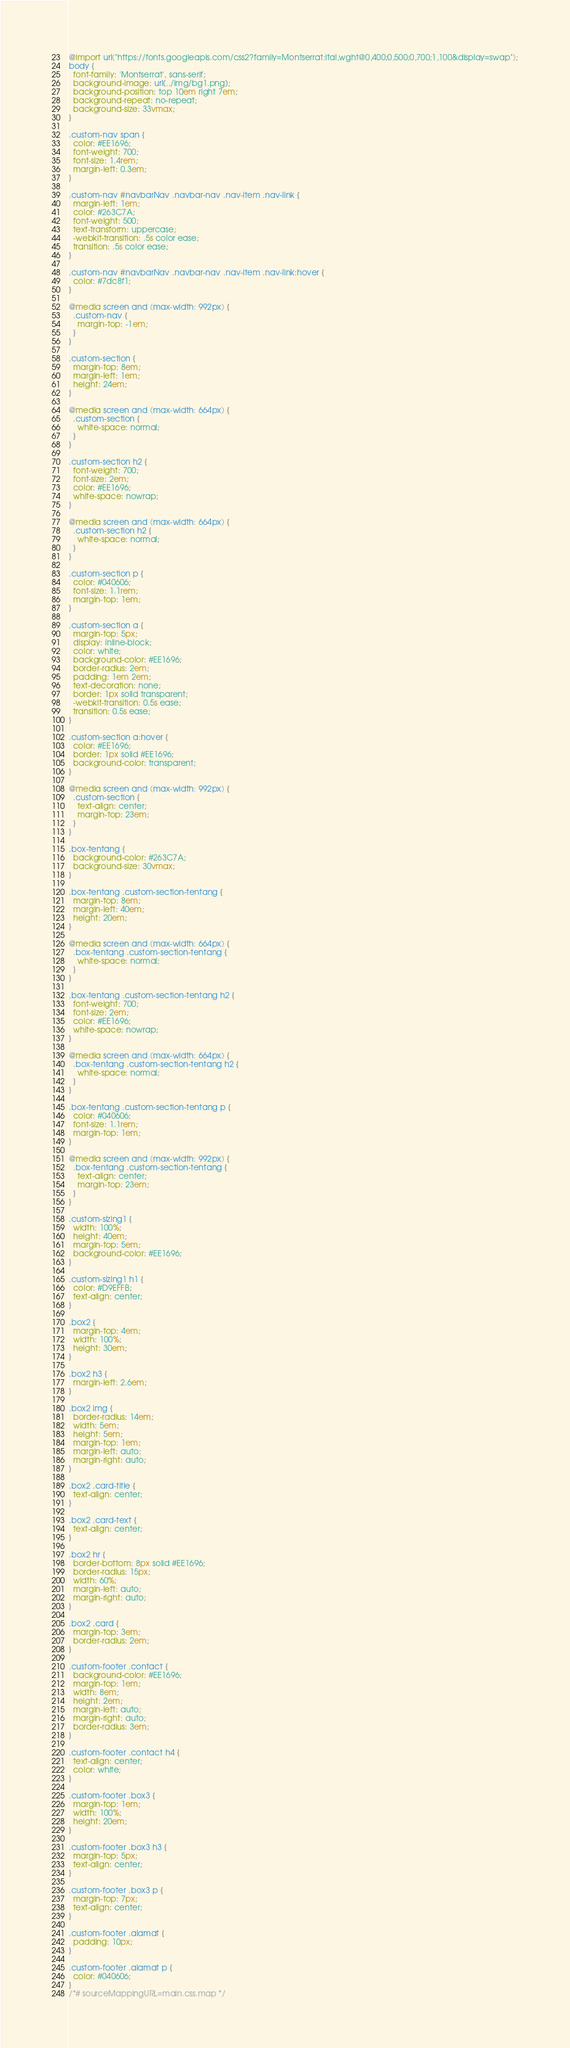Convert code to text. <code><loc_0><loc_0><loc_500><loc_500><_CSS_>@import url("https://fonts.googleapis.com/css2?family=Montserrat:ital,wght@0,400;0,500;0,700;1,100&display=swap");
body {
  font-family: 'Montserrat', sans-serif;
  background-image: url(../img/bg1.png);
  background-position: top 10em right 7em;
  background-repeat: no-repeat;
  background-size: 33vmax;
}

.custom-nav span {
  color: #EE1696;
  font-weight: 700;
  font-size: 1.4rem;
  margin-left: 0.3em;
}

.custom-nav #navbarNav .navbar-nav .nav-item .nav-link {
  margin-left: 1em;
  color: #263C7A;
  font-weight: 500;
  text-transform: uppercase;
  -webkit-transition: .5s color ease;
  transition: .5s color ease;
}

.custom-nav #navbarNav .navbar-nav .nav-item .nav-link:hover {
  color: #7dc8f1;
}

@media screen and (max-width: 992px) {
  .custom-nav {
    margin-top: -1em;
  }
}

.custom-section {
  margin-top: 8em;
  margin-left: 1em;
  height: 24em;
}

@media screen and (max-width: 664px) {
  .custom-section {
    white-space: normal;
  }
}

.custom-section h2 {
  font-weight: 700;
  font-size: 2em;
  color: #EE1696;
  white-space: nowrap;
}

@media screen and (max-width: 664px) {
  .custom-section h2 {
    white-space: normal;
  }
}

.custom-section p {
  color: #040606;
  font-size: 1.1rem;
  margin-top: 1em;
}

.custom-section a {
  margin-top: 5px;
  display: inline-block;
  color: white;
  background-color: #EE1696;
  border-radius: 2em;
  padding: 1em 2em;
  text-decoration: none;
  border: 1px solid transparent;
  -webkit-transition: 0.5s ease;
  transition: 0.5s ease;
}

.custom-section a:hover {
  color: #EE1696;
  border: 1px solid #EE1696;
  background-color: transparent;
}

@media screen and (max-width: 992px) {
  .custom-section {
    text-align: center;
    margin-top: 23em;
  }
}

.box-tentang {
  background-color: #263C7A;
  background-size: 30vmax;
}

.box-tentang .custom-section-tentang {
  margin-top: 8em;
  margin-left: 40em;
  height: 20em;
}

@media screen and (max-width: 664px) {
  .box-tentang .custom-section-tentang {
    white-space: normal;
  }
}

.box-tentang .custom-section-tentang h2 {
  font-weight: 700;
  font-size: 2em;
  color: #EE1696;
  white-space: nowrap;
}

@media screen and (max-width: 664px) {
  .box-tentang .custom-section-tentang h2 {
    white-space: normal;
  }
}

.box-tentang .custom-section-tentang p {
  color: #040606;
  font-size: 1.1rem;
  margin-top: 1em;
}

@media screen and (max-width: 992px) {
  .box-tentang .custom-section-tentang {
    text-align: center;
    margin-top: 23em;
  }
}

.custom-sizing1 {
  width: 100%;
  height: 40em;
  margin-top: 5em;
  background-color: #EE1696;
}

.custom-sizing1 h1 {
  color: #D9EFFB;
  text-align: center;
}

.box2 {
  margin-top: 4em;
  width: 100%;
  height: 30em;
}

.box2 h3 {
  margin-left: 2.6em;
}

.box2 img {
  border-radius: 14em;
  width: 5em;
  height: 5em;
  margin-top: 1em;
  margin-left: auto;
  margin-right: auto;
}

.box2 .card-title {
  text-align: center;
}

.box2 .card-text {
  text-align: center;
}

.box2 hr {
  border-bottom: 8px solid #EE1696;
  border-radius: 15px;
  width: 60%;
  margin-left: auto;
  margin-right: auto;
}

.box2 .card {
  margin-top: 3em;
  border-radius: 2em;
}

.custom-footer .contact {
  background-color: #EE1696;
  margin-top: 1em;
  width: 8em;
  height: 2em;
  margin-left: auto;
  margin-right: auto;
  border-radius: 3em;
}

.custom-footer .contact h4 {
  text-align: center;
  color: white;
}

.custom-footer .box3 {
  margin-top: 1em;
  width: 100%;
  height: 20em;
}

.custom-footer .box3 h3 {
  margin-top: 5px;
  text-align: center;
}

.custom-footer .box3 p {
  margin-top: 7px;
  text-align: center;
}

.custom-footer .alamat {
  padding: 10px;
}

.custom-footer .alamat p {
  color: #040606;
}
/*# sourceMappingURL=main.css.map */</code> 